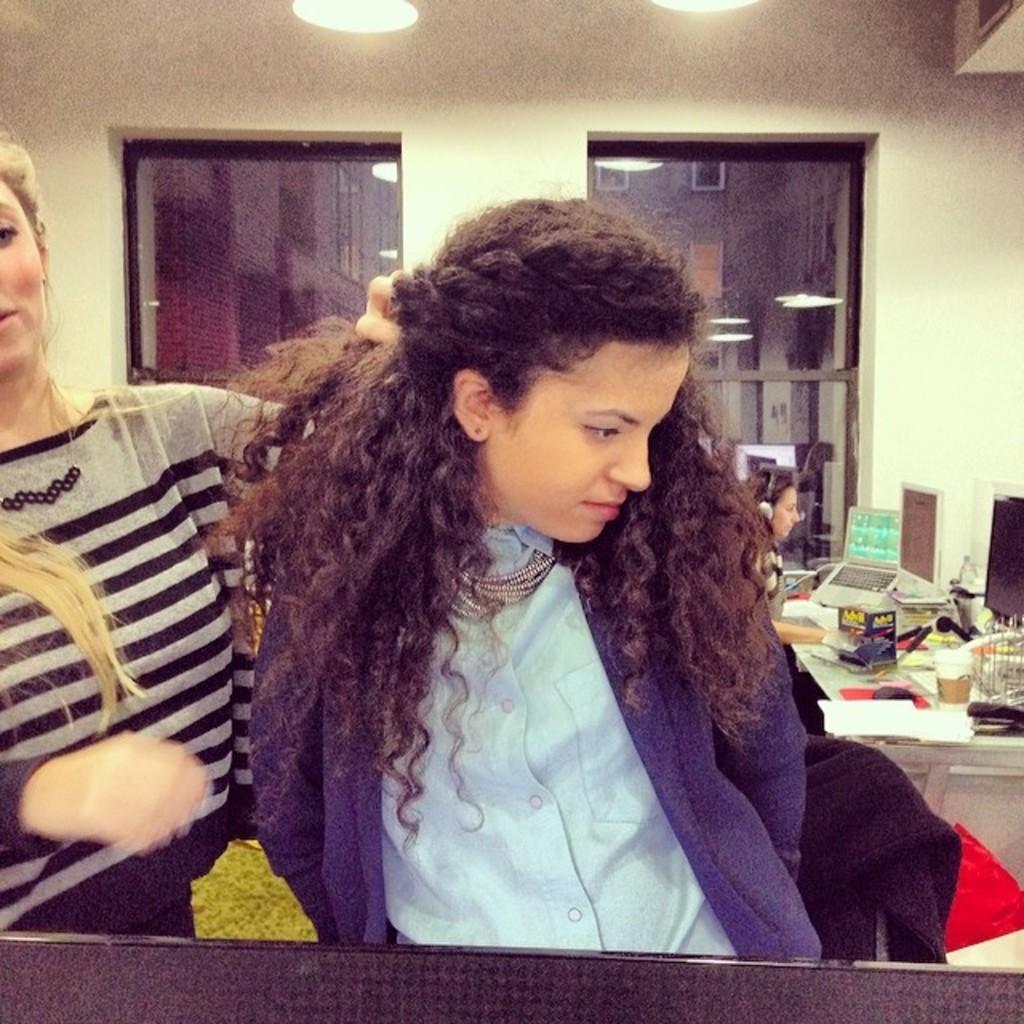Describe this image in one or two sentences. In this image we can see there are people. There are monitors and objects on the table. There are lights. There is a wall. 